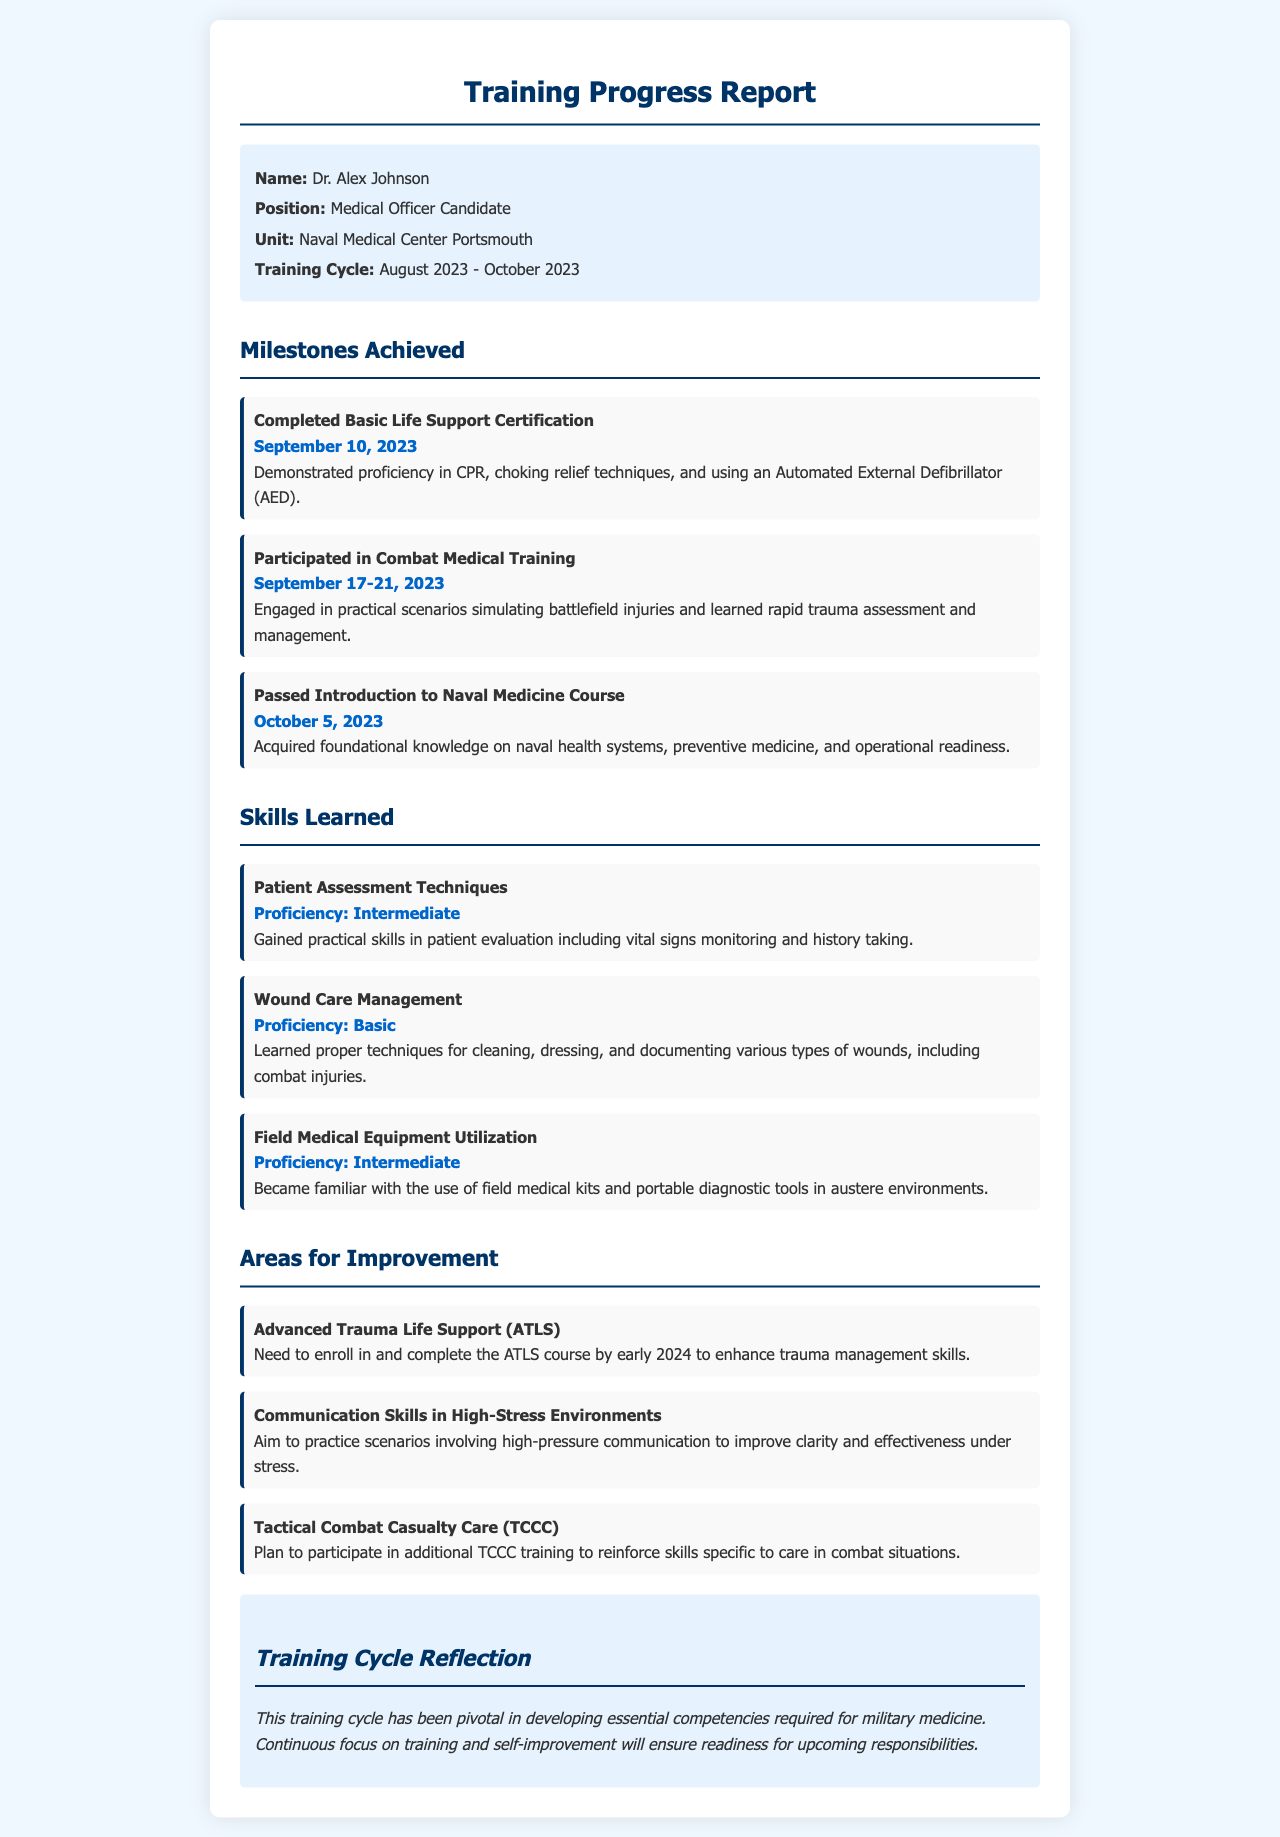what is the name of the medical officer candidate? The name mentioned in the document is Dr. Alex Johnson, who is the Medical Officer Candidate.
Answer: Dr. Alex Johnson what position does Dr. Alex Johnson hold? Dr. Alex Johnson is specified to hold the position of Medical Officer Candidate in the document.
Answer: Medical Officer Candidate when did Dr. Alex Johnson complete the Basic Life Support Certification? The date provided for the completion of Basic Life Support Certification by Dr. Alex Johnson is September 10, 2023.
Answer: September 10, 2023 what skill proficiency level did Dr. Alex Johnson achieve in Patient Assessment Techniques? The document states that Dr. Alex Johnson achieved an Intermediate proficiency level in Patient Assessment Techniques.
Answer: Intermediate which training course does Dr. Alex Johnson need to enroll in by early 2024? The document notes that Dr. Alex Johnson needs to enroll in and complete the Advanced Trauma Life Support (ATLS) course.
Answer: Advanced Trauma Life Support (ATLS) how many days did Dr. Alex Johnson participate in Combat Medical Training? The document states that Dr. Alex Johnson participated in Combat Medical Training for 5 days, from September 17 to 21, 2023.
Answer: 5 days what is one area Dr. Alex Johnson aims to improve in? The document lists several areas for improvement, one of which is Communication Skills in High-Stress Environments.
Answer: Communication Skills in High-Stress Environments what is the total duration of the training cycle mentioned? The training cycle spans from August 2023 to October 2023, which is approximately 2 months.
Answer: 2 months what reflective statement did Dr. Alex Johnson make about the training cycle? The reflection emphasizes that the training cycle was pivotal in developing essential competencies for military medicine.
Answer: Pivotal in developing essential competencies for military medicine 